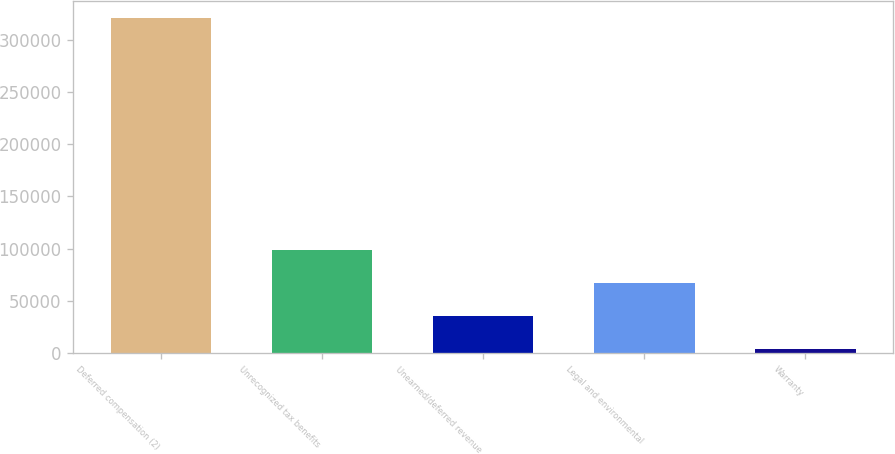Convert chart. <chart><loc_0><loc_0><loc_500><loc_500><bar_chart><fcel>Deferred compensation (2)<fcel>Unrecognized tax benefits<fcel>Unearned/deferred revenue<fcel>Legal and environmental<fcel>Warranty<nl><fcel>321736<fcel>98690.8<fcel>34963.6<fcel>66827.2<fcel>3100<nl></chart> 